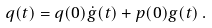Convert formula to latex. <formula><loc_0><loc_0><loc_500><loc_500>q ( t ) = q ( 0 ) \dot { g } ( t ) + p ( 0 ) g ( t ) \, .</formula> 